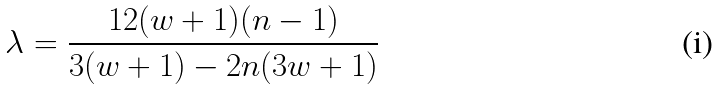Convert formula to latex. <formula><loc_0><loc_0><loc_500><loc_500>\lambda = \frac { 1 2 ( w + 1 ) ( n - 1 ) } { 3 ( w + 1 ) - 2 n ( 3 w + 1 ) }</formula> 